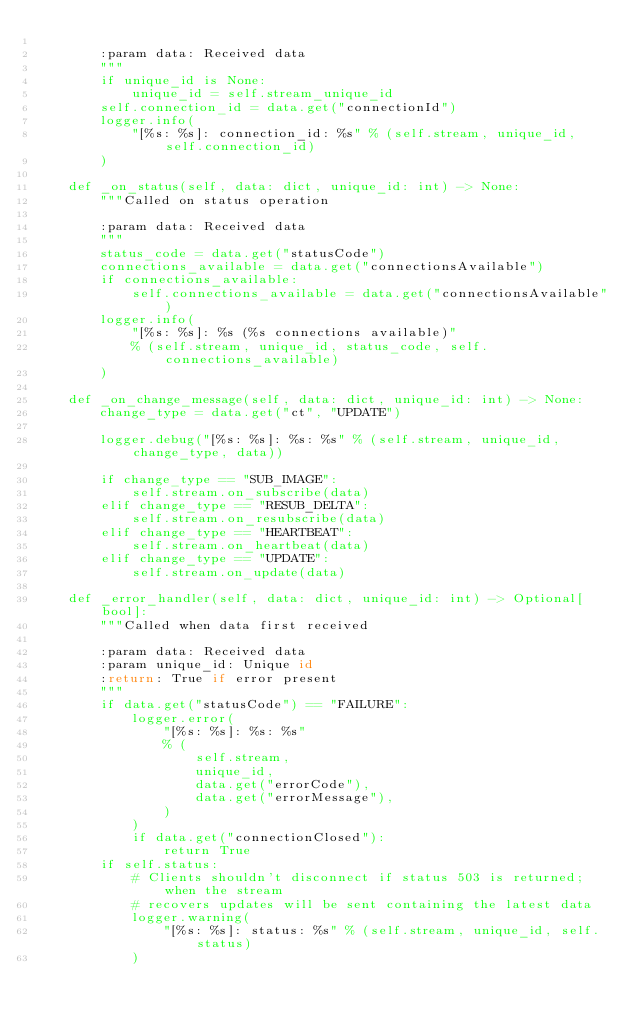Convert code to text. <code><loc_0><loc_0><loc_500><loc_500><_Python_>
        :param data: Received data
        """
        if unique_id is None:
            unique_id = self.stream_unique_id
        self.connection_id = data.get("connectionId")
        logger.info(
            "[%s: %s]: connection_id: %s" % (self.stream, unique_id, self.connection_id)
        )

    def _on_status(self, data: dict, unique_id: int) -> None:
        """Called on status operation

        :param data: Received data
        """
        status_code = data.get("statusCode")
        connections_available = data.get("connectionsAvailable")
        if connections_available:
            self.connections_available = data.get("connectionsAvailable")
        logger.info(
            "[%s: %s]: %s (%s connections available)"
            % (self.stream, unique_id, status_code, self.connections_available)
        )

    def _on_change_message(self, data: dict, unique_id: int) -> None:
        change_type = data.get("ct", "UPDATE")

        logger.debug("[%s: %s]: %s: %s" % (self.stream, unique_id, change_type, data))

        if change_type == "SUB_IMAGE":
            self.stream.on_subscribe(data)
        elif change_type == "RESUB_DELTA":
            self.stream.on_resubscribe(data)
        elif change_type == "HEARTBEAT":
            self.stream.on_heartbeat(data)
        elif change_type == "UPDATE":
            self.stream.on_update(data)

    def _error_handler(self, data: dict, unique_id: int) -> Optional[bool]:
        """Called when data first received

        :param data: Received data
        :param unique_id: Unique id
        :return: True if error present
        """
        if data.get("statusCode") == "FAILURE":
            logger.error(
                "[%s: %s]: %s: %s"
                % (
                    self.stream,
                    unique_id,
                    data.get("errorCode"),
                    data.get("errorMessage"),
                )
            )
            if data.get("connectionClosed"):
                return True
        if self.status:
            # Clients shouldn't disconnect if status 503 is returned; when the stream
            # recovers updates will be sent containing the latest data
            logger.warning(
                "[%s: %s]: status: %s" % (self.stream, unique_id, self.status)
            )
</code> 